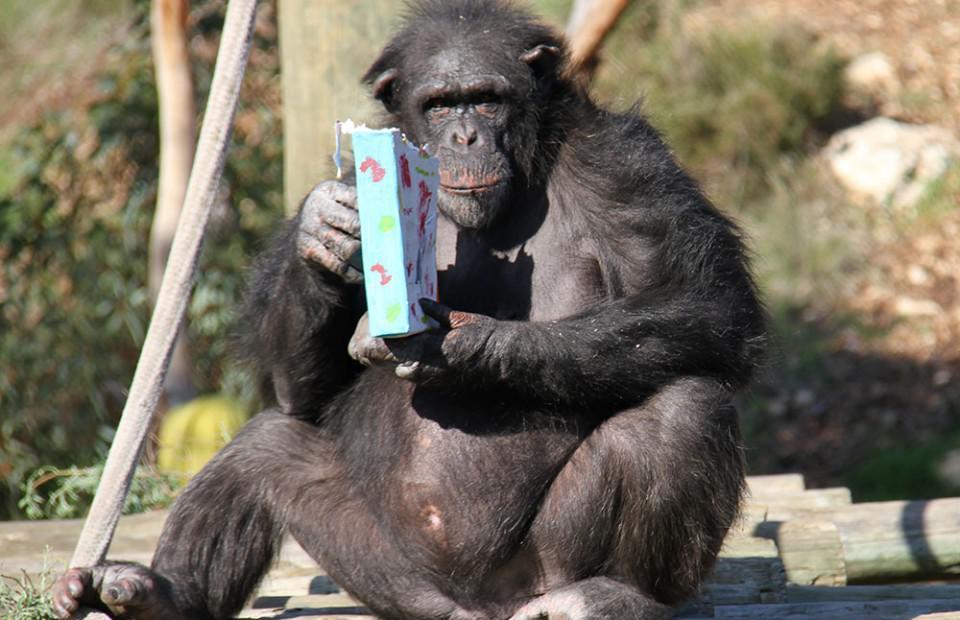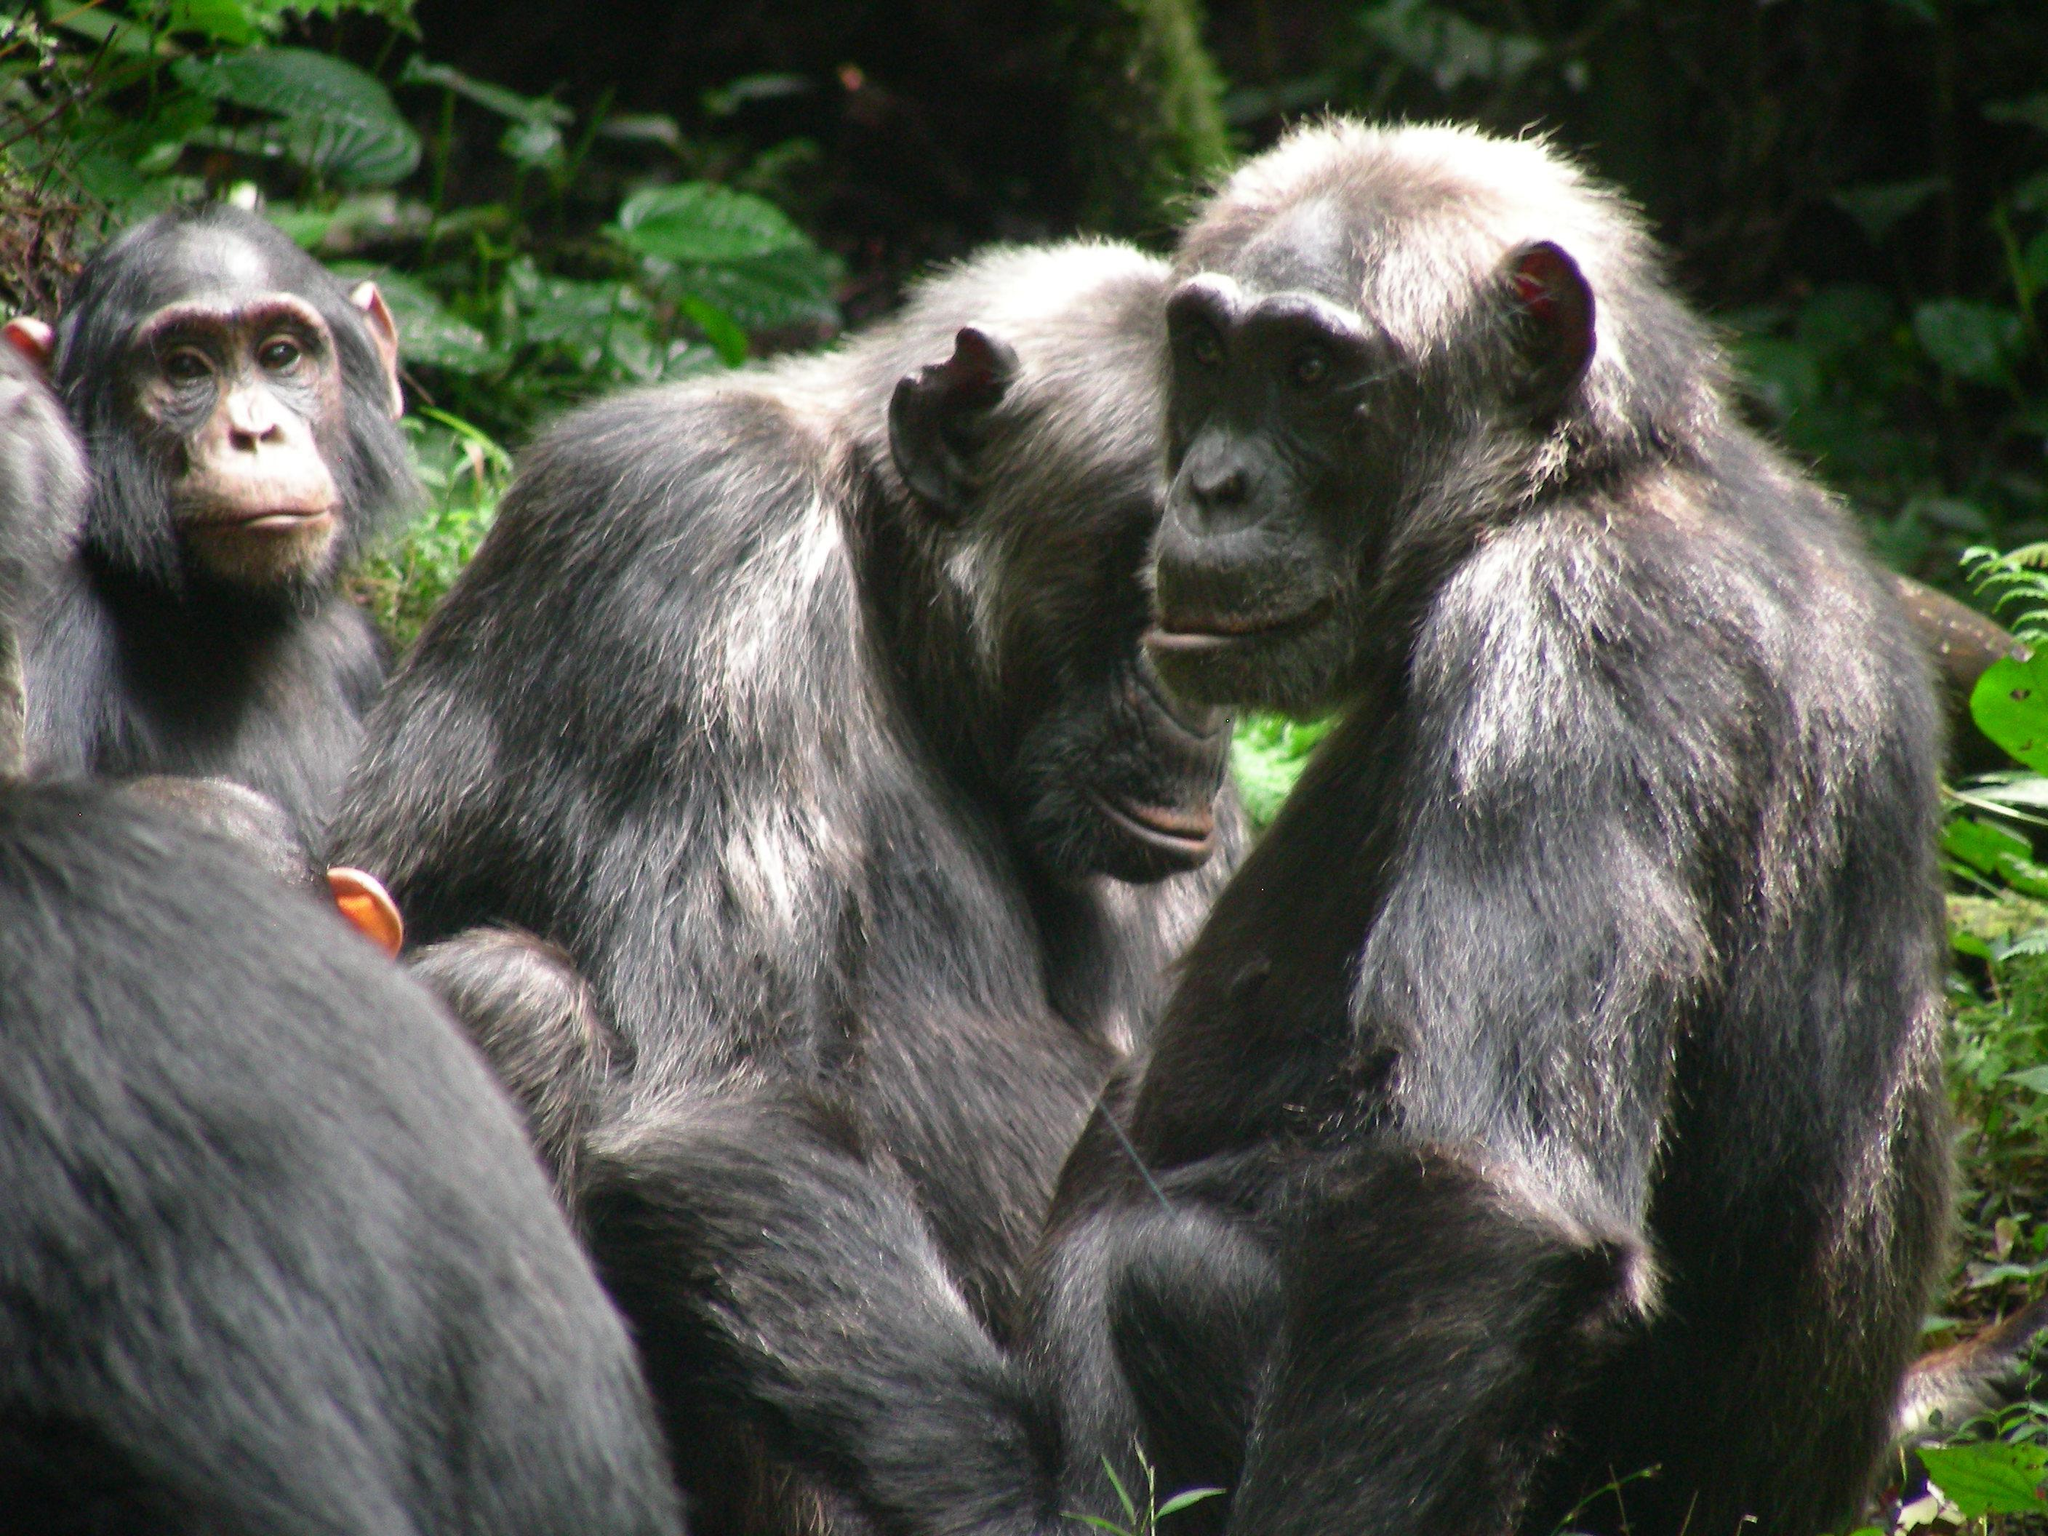The first image is the image on the left, the second image is the image on the right. Evaluate the accuracy of this statement regarding the images: "In one image there is a single chimpanzee and in the other there is a group of at least four.". Is it true? Answer yes or no. Yes. The first image is the image on the left, the second image is the image on the right. Considering the images on both sides, is "There are a total of 5 monkeys present outside." valid? Answer yes or no. Yes. 